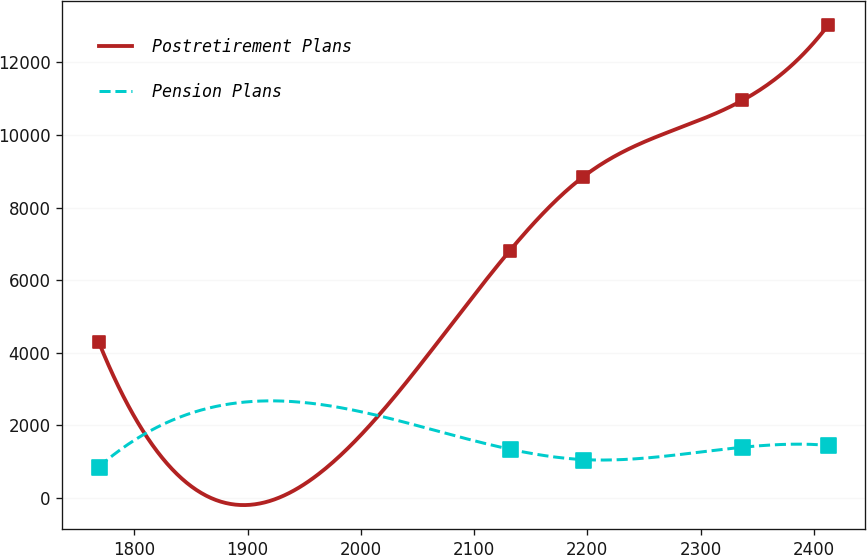Convert chart. <chart><loc_0><loc_0><loc_500><loc_500><line_chart><ecel><fcel>Postretirement Plans<fcel>Pension Plans<nl><fcel>1768.57<fcel>4285.21<fcel>848.11<nl><fcel>2131.53<fcel>6809.61<fcel>1334.61<nl><fcel>2195.94<fcel>8837.4<fcel>1048.52<nl><fcel>2337<fcel>10955.6<fcel>1387.21<nl><fcel>2412.68<fcel>13029.4<fcel>1439.81<nl></chart> 